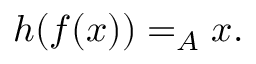Convert formula to latex. <formula><loc_0><loc_0><loc_500><loc_500>h ( f ( x ) ) = _ { A } x .</formula> 